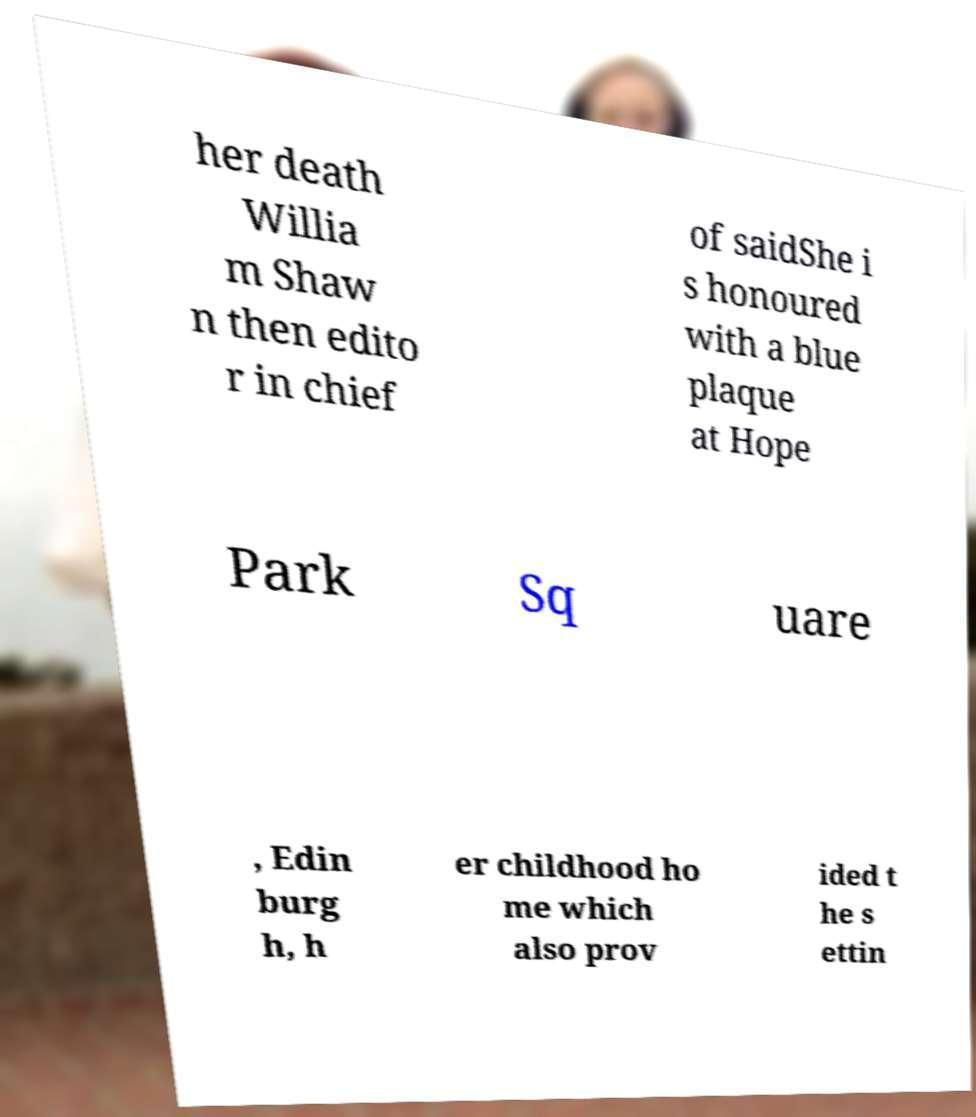What messages or text are displayed in this image? I need them in a readable, typed format. her death Willia m Shaw n then edito r in chief of saidShe i s honoured with a blue plaque at Hope Park Sq uare , Edin burg h, h er childhood ho me which also prov ided t he s ettin 